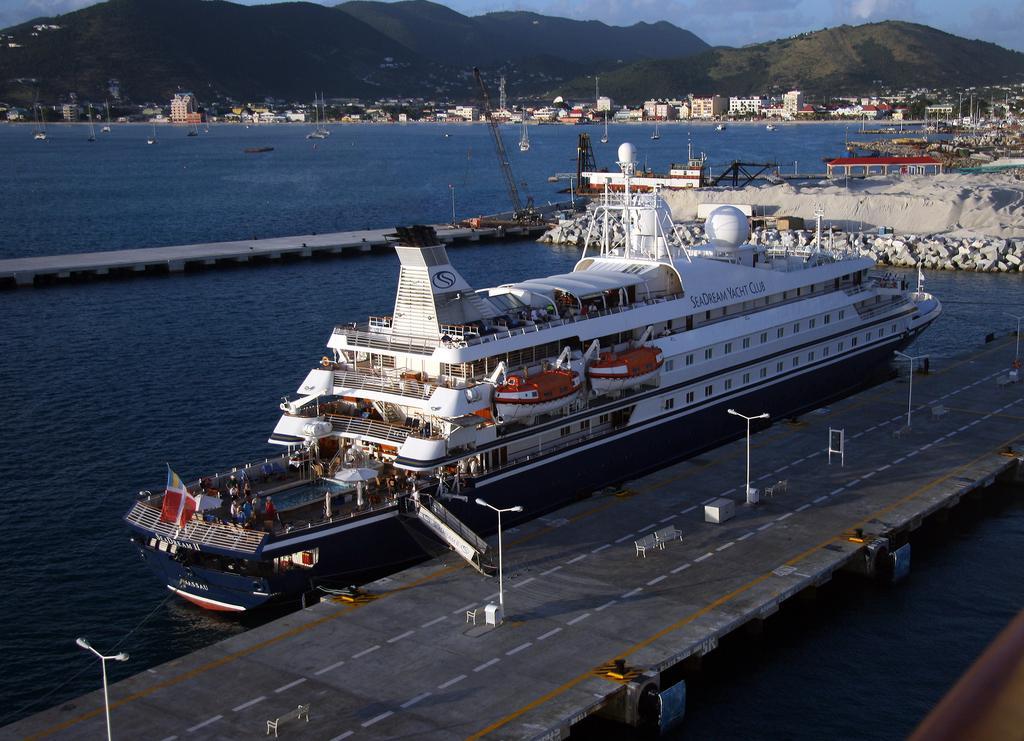Could you give a brief overview of what you see in this image? In this image we can see a ship on the water, there are few people and a flag in the ship, beside the ship there is a bridge, on the bridge there are light poles, chairs and a few objects, in the background there are rocks, sand , buildings, mountains and sky. 